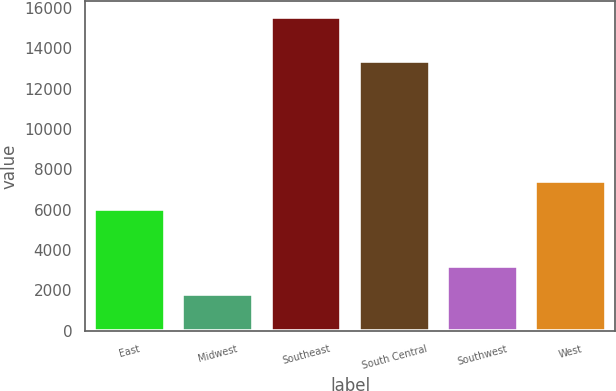<chart> <loc_0><loc_0><loc_500><loc_500><bar_chart><fcel>East<fcel>Midwest<fcel>Southeast<fcel>South Central<fcel>Southwest<fcel>West<nl><fcel>6039<fcel>1841<fcel>15575<fcel>13374<fcel>3214.4<fcel>7412.4<nl></chart> 